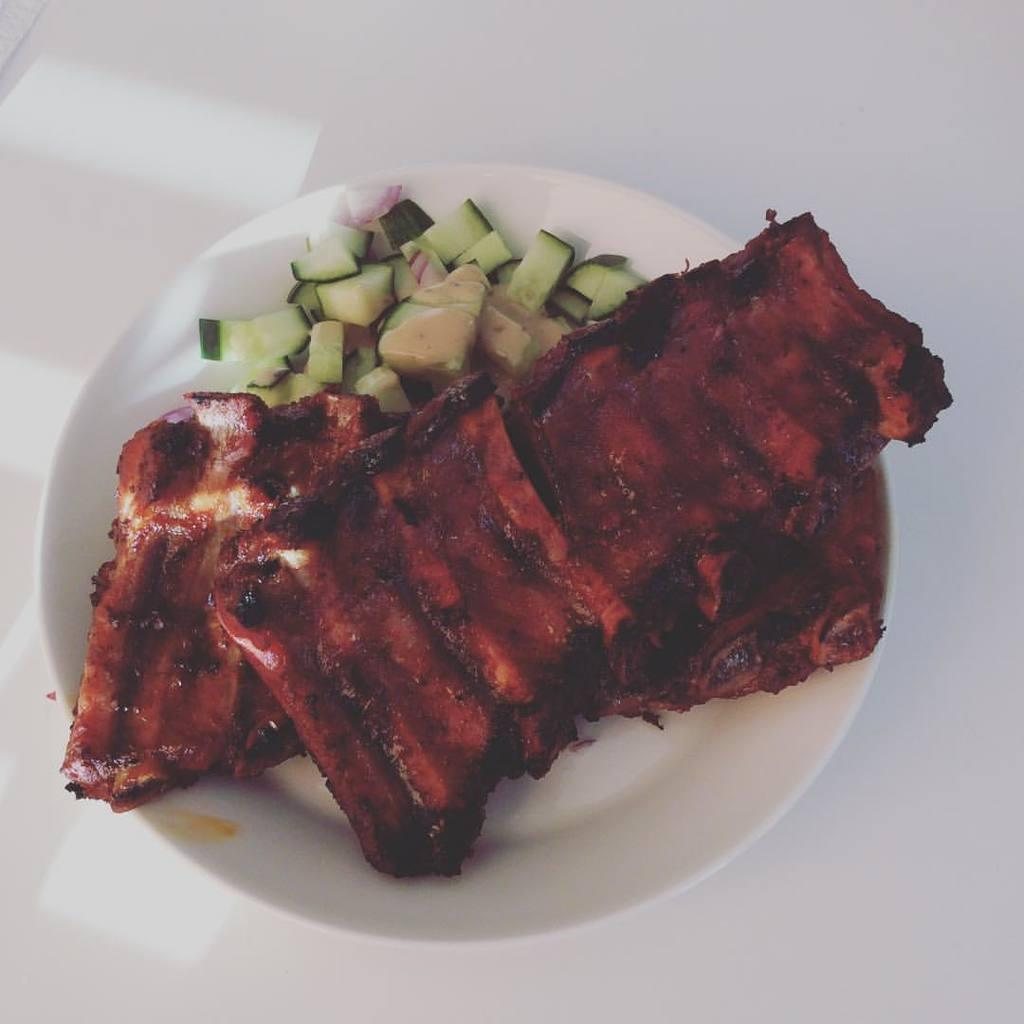What types of food are visible in the image? There are meat pieces and cucumber pieces in the image. In what container are the meat and cucumber pieces located? The meat and cucumber pieces are in a white bowl. What color is the bowl containing the food? The bowl is white. What is the surface beneath the white bowl? The white bowl is placed on a white surface. What type of spark can be seen coming from the cucumber pieces in the image? There is no spark present in the image; it features meat and cucumber pieces in a white bowl on a white surface. 